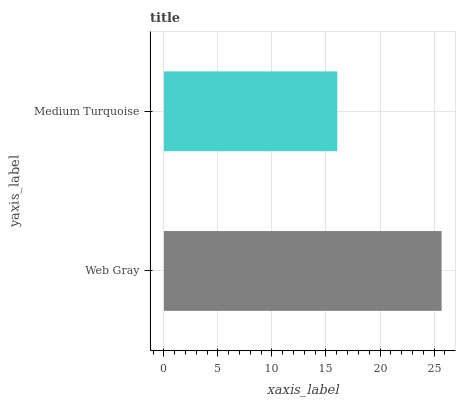Is Medium Turquoise the minimum?
Answer yes or no. Yes. Is Web Gray the maximum?
Answer yes or no. Yes. Is Medium Turquoise the maximum?
Answer yes or no. No. Is Web Gray greater than Medium Turquoise?
Answer yes or no. Yes. Is Medium Turquoise less than Web Gray?
Answer yes or no. Yes. Is Medium Turquoise greater than Web Gray?
Answer yes or no. No. Is Web Gray less than Medium Turquoise?
Answer yes or no. No. Is Web Gray the high median?
Answer yes or no. Yes. Is Medium Turquoise the low median?
Answer yes or no. Yes. Is Medium Turquoise the high median?
Answer yes or no. No. Is Web Gray the low median?
Answer yes or no. No. 